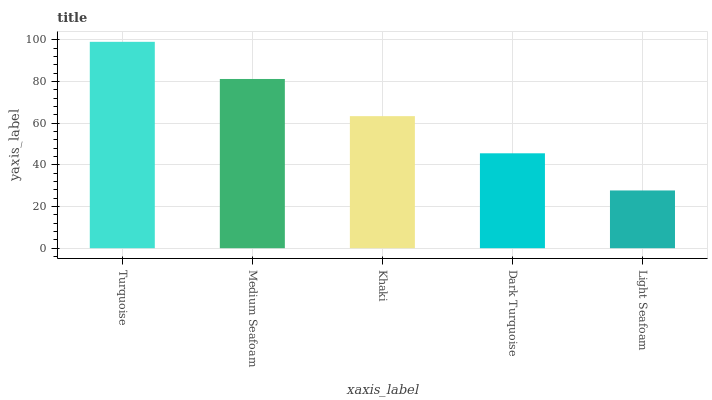Is Light Seafoam the minimum?
Answer yes or no. Yes. Is Turquoise the maximum?
Answer yes or no. Yes. Is Medium Seafoam the minimum?
Answer yes or no. No. Is Medium Seafoam the maximum?
Answer yes or no. No. Is Turquoise greater than Medium Seafoam?
Answer yes or no. Yes. Is Medium Seafoam less than Turquoise?
Answer yes or no. Yes. Is Medium Seafoam greater than Turquoise?
Answer yes or no. No. Is Turquoise less than Medium Seafoam?
Answer yes or no. No. Is Khaki the high median?
Answer yes or no. Yes. Is Khaki the low median?
Answer yes or no. Yes. Is Medium Seafoam the high median?
Answer yes or no. No. Is Light Seafoam the low median?
Answer yes or no. No. 